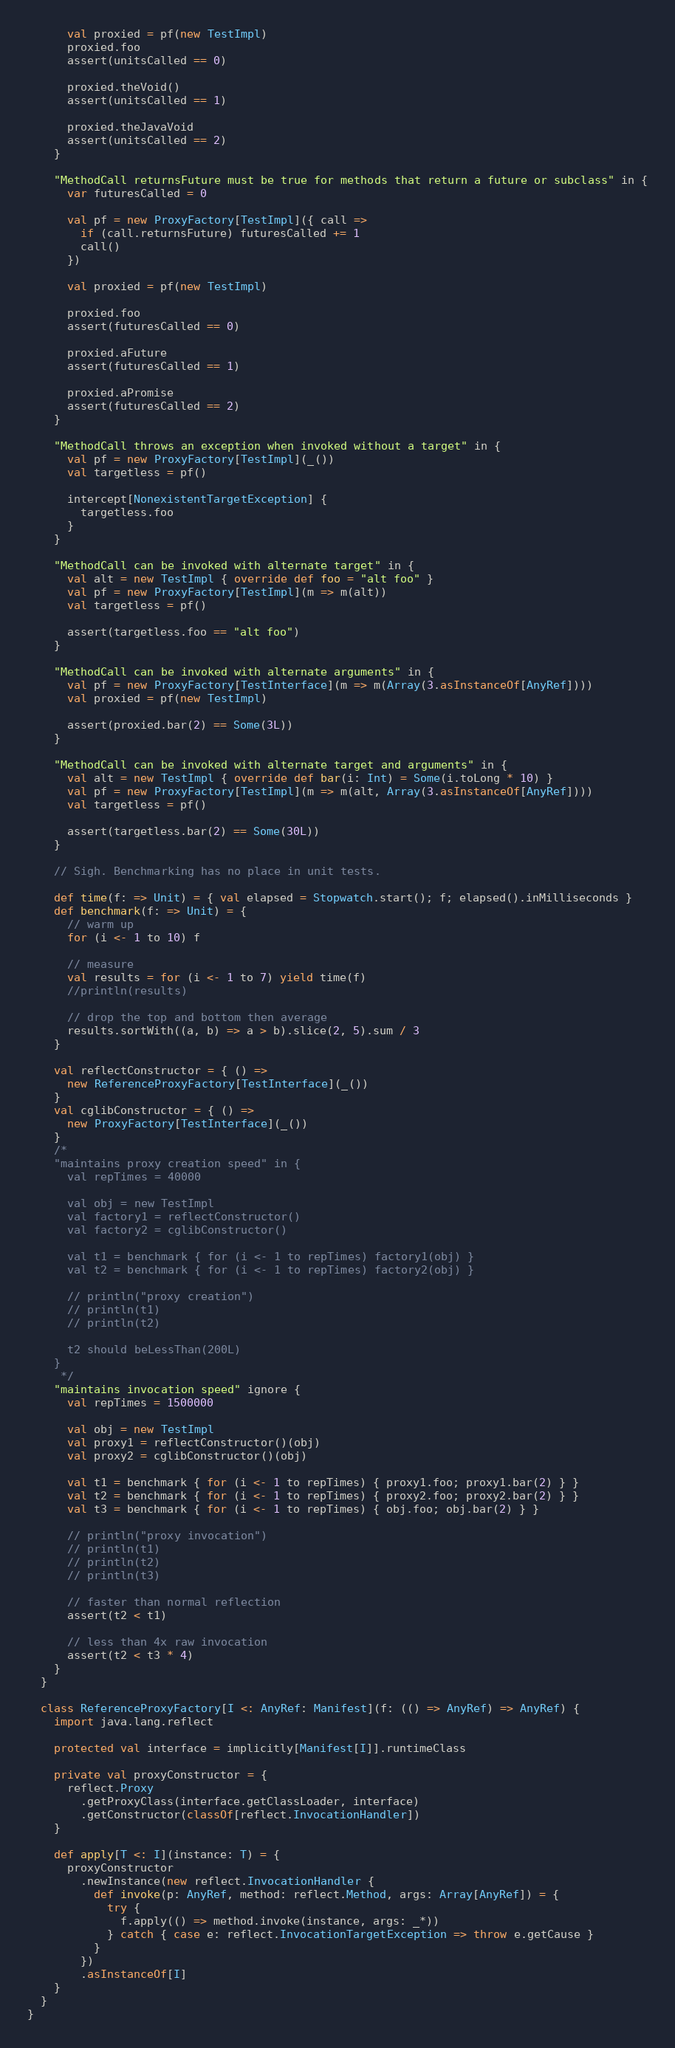Convert code to text. <code><loc_0><loc_0><loc_500><loc_500><_Scala_>
      val proxied = pf(new TestImpl)
      proxied.foo
      assert(unitsCalled == 0)

      proxied.theVoid()
      assert(unitsCalled == 1)

      proxied.theJavaVoid
      assert(unitsCalled == 2)
    }

    "MethodCall returnsFuture must be true for methods that return a future or subclass" in {
      var futuresCalled = 0

      val pf = new ProxyFactory[TestImpl]({ call =>
        if (call.returnsFuture) futuresCalled += 1
        call()
      })

      val proxied = pf(new TestImpl)

      proxied.foo
      assert(futuresCalled == 0)

      proxied.aFuture
      assert(futuresCalled == 1)

      proxied.aPromise
      assert(futuresCalled == 2)
    }

    "MethodCall throws an exception when invoked without a target" in {
      val pf = new ProxyFactory[TestImpl](_())
      val targetless = pf()

      intercept[NonexistentTargetException] {
        targetless.foo
      }
    }

    "MethodCall can be invoked with alternate target" in {
      val alt = new TestImpl { override def foo = "alt foo" }
      val pf = new ProxyFactory[TestImpl](m => m(alt))
      val targetless = pf()

      assert(targetless.foo == "alt foo")
    }

    "MethodCall can be invoked with alternate arguments" in {
      val pf = new ProxyFactory[TestInterface](m => m(Array(3.asInstanceOf[AnyRef])))
      val proxied = pf(new TestImpl)

      assert(proxied.bar(2) == Some(3L))
    }

    "MethodCall can be invoked with alternate target and arguments" in {
      val alt = new TestImpl { override def bar(i: Int) = Some(i.toLong * 10) }
      val pf = new ProxyFactory[TestImpl](m => m(alt, Array(3.asInstanceOf[AnyRef])))
      val targetless = pf()

      assert(targetless.bar(2) == Some(30L))
    }

    // Sigh. Benchmarking has no place in unit tests.

    def time(f: => Unit) = { val elapsed = Stopwatch.start(); f; elapsed().inMilliseconds }
    def benchmark(f: => Unit) = {
      // warm up
      for (i <- 1 to 10) f

      // measure
      val results = for (i <- 1 to 7) yield time(f)
      //println(results)

      // drop the top and bottom then average
      results.sortWith((a, b) => a > b).slice(2, 5).sum / 3
    }

    val reflectConstructor = { () =>
      new ReferenceProxyFactory[TestInterface](_())
    }
    val cglibConstructor = { () =>
      new ProxyFactory[TestInterface](_())
    }
    /*
    "maintains proxy creation speed" in {
      val repTimes = 40000

      val obj = new TestImpl
      val factory1 = reflectConstructor()
      val factory2 = cglibConstructor()

      val t1 = benchmark { for (i <- 1 to repTimes) factory1(obj) }
      val t2 = benchmark { for (i <- 1 to repTimes) factory2(obj) }

      // println("proxy creation")
      // println(t1)
      // println(t2)

      t2 should beLessThan(200L)
    }
     */
    "maintains invocation speed" ignore {
      val repTimes = 1500000

      val obj = new TestImpl
      val proxy1 = reflectConstructor()(obj)
      val proxy2 = cglibConstructor()(obj)

      val t1 = benchmark { for (i <- 1 to repTimes) { proxy1.foo; proxy1.bar(2) } }
      val t2 = benchmark { for (i <- 1 to repTimes) { proxy2.foo; proxy2.bar(2) } }
      val t3 = benchmark { for (i <- 1 to repTimes) { obj.foo; obj.bar(2) } }

      // println("proxy invocation")
      // println(t1)
      // println(t2)
      // println(t3)

      // faster than normal reflection
      assert(t2 < t1)

      // less than 4x raw invocation
      assert(t2 < t3 * 4)
    }
  }

  class ReferenceProxyFactory[I <: AnyRef: Manifest](f: (() => AnyRef) => AnyRef) {
    import java.lang.reflect

    protected val interface = implicitly[Manifest[I]].runtimeClass

    private val proxyConstructor = {
      reflect.Proxy
        .getProxyClass(interface.getClassLoader, interface)
        .getConstructor(classOf[reflect.InvocationHandler])
    }

    def apply[T <: I](instance: T) = {
      proxyConstructor
        .newInstance(new reflect.InvocationHandler {
          def invoke(p: AnyRef, method: reflect.Method, args: Array[AnyRef]) = {
            try {
              f.apply(() => method.invoke(instance, args: _*))
            } catch { case e: reflect.InvocationTargetException => throw e.getCause }
          }
        })
        .asInstanceOf[I]
    }
  }
}
</code> 